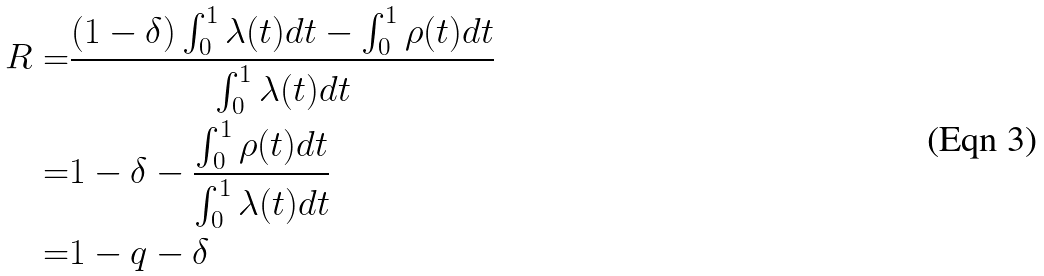<formula> <loc_0><loc_0><loc_500><loc_500>R = & \frac { ( 1 - \delta ) \int _ { 0 } ^ { 1 } \lambda ( t ) d t - \int _ { 0 } ^ { 1 } \rho ( t ) d t } { \int _ { 0 } ^ { 1 } \lambda ( t ) d t } \\ = & 1 - \delta - \frac { \int _ { 0 } ^ { 1 } \rho ( t ) d t } { \int _ { 0 } ^ { 1 } \lambda ( t ) d t } \\ = & 1 - q - \delta</formula> 